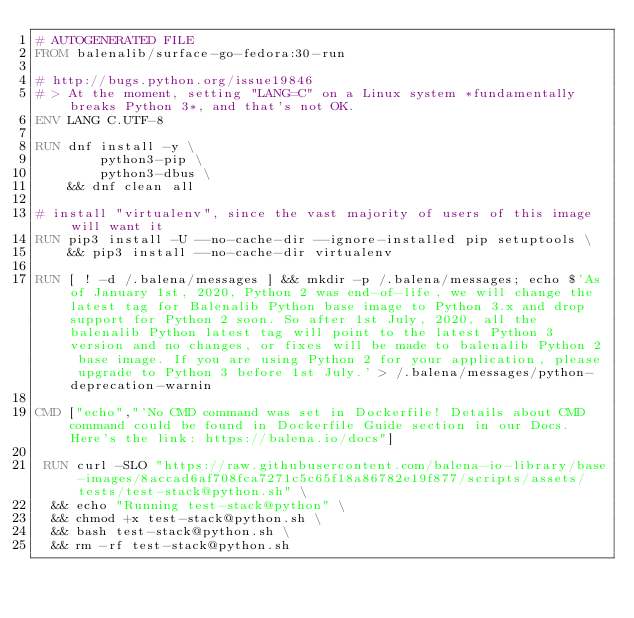<code> <loc_0><loc_0><loc_500><loc_500><_Dockerfile_># AUTOGENERATED FILE
FROM balenalib/surface-go-fedora:30-run

# http://bugs.python.org/issue19846
# > At the moment, setting "LANG=C" on a Linux system *fundamentally breaks Python 3*, and that's not OK.
ENV LANG C.UTF-8

RUN dnf install -y \
		python3-pip \
		python3-dbus \
	&& dnf clean all

# install "virtualenv", since the vast majority of users of this image will want it
RUN pip3 install -U --no-cache-dir --ignore-installed pip setuptools \
	&& pip3 install --no-cache-dir virtualenv

RUN [ ! -d /.balena/messages ] && mkdir -p /.balena/messages; echo $'As of January 1st, 2020, Python 2 was end-of-life, we will change the latest tag for Balenalib Python base image to Python 3.x and drop support for Python 2 soon. So after 1st July, 2020, all the balenalib Python latest tag will point to the latest Python 3 version and no changes, or fixes will be made to balenalib Python 2 base image. If you are using Python 2 for your application, please upgrade to Python 3 before 1st July.' > /.balena/messages/python-deprecation-warnin

CMD ["echo","'No CMD command was set in Dockerfile! Details about CMD command could be found in Dockerfile Guide section in our Docs. Here's the link: https://balena.io/docs"]

 RUN curl -SLO "https://raw.githubusercontent.com/balena-io-library/base-images/8accad6af708fca7271c5c65f18a86782e19f877/scripts/assets/tests/test-stack@python.sh" \
  && echo "Running test-stack@python" \
  && chmod +x test-stack@python.sh \
  && bash test-stack@python.sh \
  && rm -rf test-stack@python.sh 
</code> 